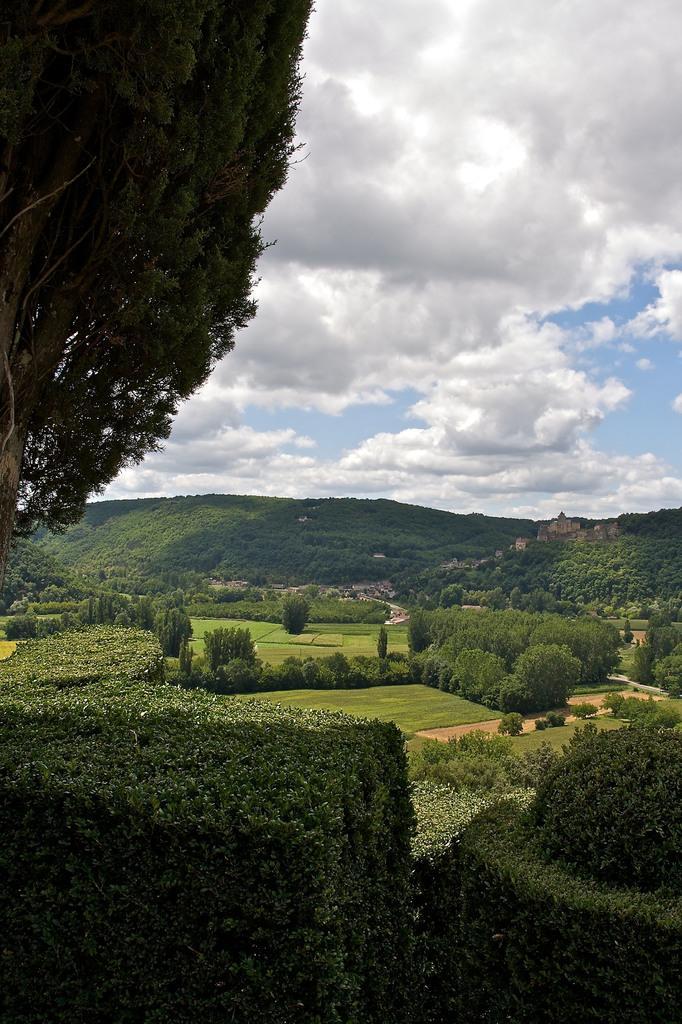How would you summarize this image in a sentence or two? In this image we can see sky with clouds, hills, trees, grounds and bushes. 